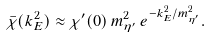Convert formula to latex. <formula><loc_0><loc_0><loc_500><loc_500>\bar { \chi } ( k ^ { 2 } _ { E } ) \approx \chi ^ { \prime } ( 0 ) \, m ^ { 2 } _ { \eta ^ { \prime } } \, e ^ { - k _ { E } ^ { 2 } / m _ { \eta ^ { \prime } } ^ { 2 } } .</formula> 